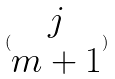Convert formula to latex. <formula><loc_0><loc_0><loc_500><loc_500>( \begin{matrix} j \\ m + 1 \end{matrix} )</formula> 